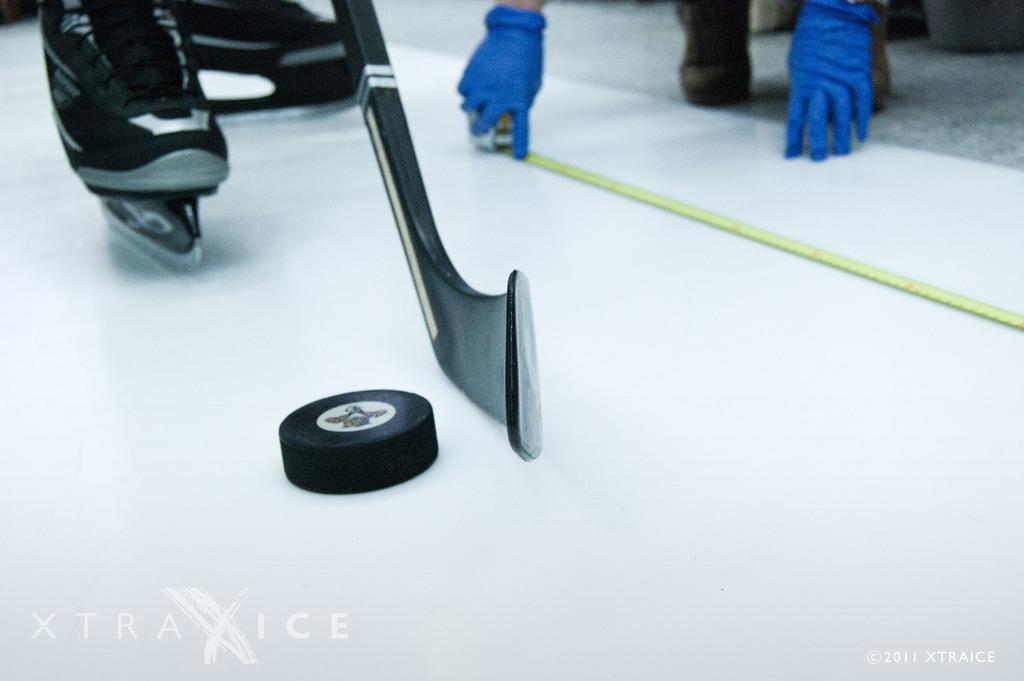What is the main subject of the image? There is an object in the image. Can you describe the person behind the object? Two legs are visible behind the object, and the person is wearing shoes with skates underneath. What can be seen in the background of the image? In the background, hands and legs of a person are visible. What type of jam is being spread on the pump in the image? There is no jam or pump present in the image. 